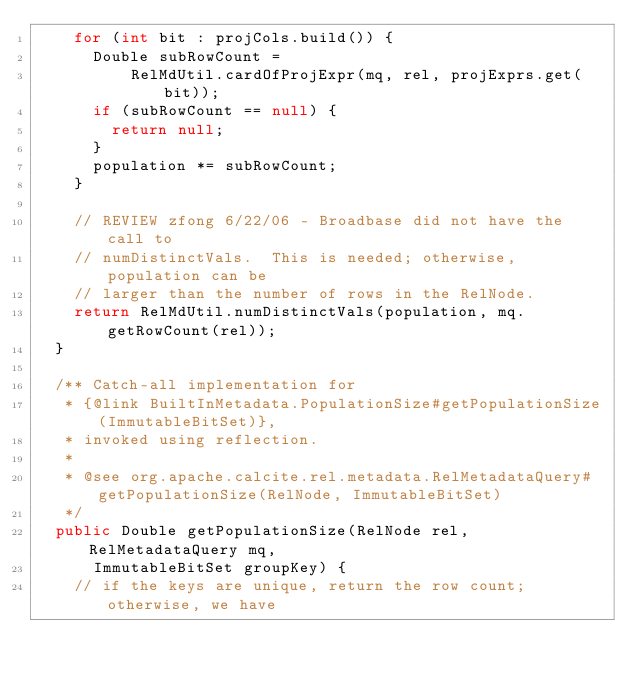<code> <loc_0><loc_0><loc_500><loc_500><_Java_>    for (int bit : projCols.build()) {
      Double subRowCount =
          RelMdUtil.cardOfProjExpr(mq, rel, projExprs.get(bit));
      if (subRowCount == null) {
        return null;
      }
      population *= subRowCount;
    }

    // REVIEW zfong 6/22/06 - Broadbase did not have the call to
    // numDistinctVals.  This is needed; otherwise, population can be
    // larger than the number of rows in the RelNode.
    return RelMdUtil.numDistinctVals(population, mq.getRowCount(rel));
  }

  /** Catch-all implementation for
   * {@link BuiltInMetadata.PopulationSize#getPopulationSize(ImmutableBitSet)},
   * invoked using reflection.
   *
   * @see org.apache.calcite.rel.metadata.RelMetadataQuery#getPopulationSize(RelNode, ImmutableBitSet)
   */
  public Double getPopulationSize(RelNode rel, RelMetadataQuery mq,
      ImmutableBitSet groupKey) {
    // if the keys are unique, return the row count; otherwise, we have</code> 